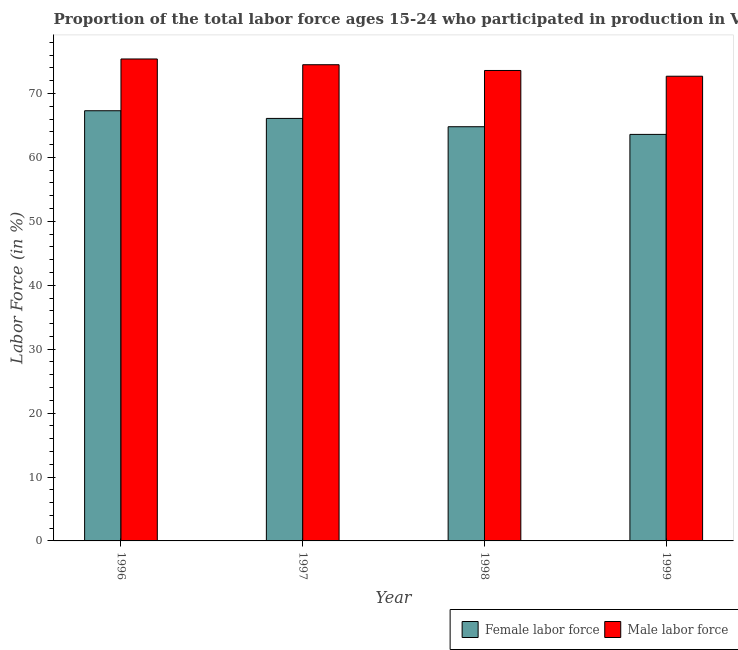How many bars are there on the 1st tick from the left?
Give a very brief answer. 2. How many bars are there on the 1st tick from the right?
Offer a terse response. 2. What is the percentage of male labour force in 1999?
Provide a succinct answer. 72.7. Across all years, what is the maximum percentage of female labor force?
Offer a very short reply. 67.3. Across all years, what is the minimum percentage of male labour force?
Ensure brevity in your answer.  72.7. In which year was the percentage of female labor force minimum?
Give a very brief answer. 1999. What is the total percentage of female labor force in the graph?
Provide a short and direct response. 261.8. What is the difference between the percentage of male labour force in 1997 and that in 1998?
Your answer should be compact. 0.9. What is the difference between the percentage of female labor force in 1997 and the percentage of male labour force in 1998?
Your answer should be very brief. 1.3. What is the average percentage of male labour force per year?
Provide a short and direct response. 74.05. What is the ratio of the percentage of female labor force in 1997 to that in 1999?
Provide a succinct answer. 1.04. Is the percentage of female labor force in 1996 less than that in 1997?
Offer a terse response. No. What is the difference between the highest and the second highest percentage of male labour force?
Ensure brevity in your answer.  0.9. What is the difference between the highest and the lowest percentage of male labour force?
Offer a very short reply. 2.7. Is the sum of the percentage of male labour force in 1996 and 1999 greater than the maximum percentage of female labor force across all years?
Keep it short and to the point. Yes. What does the 1st bar from the left in 1997 represents?
Your answer should be very brief. Female labor force. What does the 2nd bar from the right in 1996 represents?
Offer a terse response. Female labor force. Are the values on the major ticks of Y-axis written in scientific E-notation?
Your answer should be compact. No. Does the graph contain any zero values?
Your answer should be very brief. No. Does the graph contain grids?
Offer a terse response. No. What is the title of the graph?
Keep it short and to the point. Proportion of the total labor force ages 15-24 who participated in production in Vanuatu. What is the label or title of the X-axis?
Give a very brief answer. Year. What is the Labor Force (in %) of Female labor force in 1996?
Offer a very short reply. 67.3. What is the Labor Force (in %) in Male labor force in 1996?
Give a very brief answer. 75.4. What is the Labor Force (in %) in Female labor force in 1997?
Your response must be concise. 66.1. What is the Labor Force (in %) of Male labor force in 1997?
Provide a short and direct response. 74.5. What is the Labor Force (in %) in Female labor force in 1998?
Your answer should be very brief. 64.8. What is the Labor Force (in %) of Male labor force in 1998?
Keep it short and to the point. 73.6. What is the Labor Force (in %) in Female labor force in 1999?
Keep it short and to the point. 63.6. What is the Labor Force (in %) of Male labor force in 1999?
Your answer should be compact. 72.7. Across all years, what is the maximum Labor Force (in %) in Female labor force?
Offer a terse response. 67.3. Across all years, what is the maximum Labor Force (in %) of Male labor force?
Your response must be concise. 75.4. Across all years, what is the minimum Labor Force (in %) in Female labor force?
Give a very brief answer. 63.6. Across all years, what is the minimum Labor Force (in %) in Male labor force?
Make the answer very short. 72.7. What is the total Labor Force (in %) of Female labor force in the graph?
Keep it short and to the point. 261.8. What is the total Labor Force (in %) of Male labor force in the graph?
Give a very brief answer. 296.2. What is the difference between the Labor Force (in %) of Male labor force in 1996 and that in 1997?
Offer a terse response. 0.9. What is the difference between the Labor Force (in %) of Male labor force in 1996 and that in 1999?
Keep it short and to the point. 2.7. What is the difference between the Labor Force (in %) of Female labor force in 1997 and that in 1998?
Ensure brevity in your answer.  1.3. What is the difference between the Labor Force (in %) in Female labor force in 1997 and that in 1999?
Make the answer very short. 2.5. What is the difference between the Labor Force (in %) in Female labor force in 1998 and that in 1999?
Your answer should be compact. 1.2. What is the difference between the Labor Force (in %) in Female labor force in 1996 and the Labor Force (in %) in Male labor force in 1997?
Ensure brevity in your answer.  -7.2. What is the difference between the Labor Force (in %) of Female labor force in 1996 and the Labor Force (in %) of Male labor force in 1998?
Give a very brief answer. -6.3. What is the difference between the Labor Force (in %) in Female labor force in 1996 and the Labor Force (in %) in Male labor force in 1999?
Keep it short and to the point. -5.4. What is the difference between the Labor Force (in %) of Female labor force in 1997 and the Labor Force (in %) of Male labor force in 1998?
Your response must be concise. -7.5. What is the average Labor Force (in %) in Female labor force per year?
Keep it short and to the point. 65.45. What is the average Labor Force (in %) of Male labor force per year?
Make the answer very short. 74.05. In the year 1999, what is the difference between the Labor Force (in %) in Female labor force and Labor Force (in %) in Male labor force?
Offer a very short reply. -9.1. What is the ratio of the Labor Force (in %) in Female labor force in 1996 to that in 1997?
Give a very brief answer. 1.02. What is the ratio of the Labor Force (in %) in Male labor force in 1996 to that in 1997?
Your answer should be compact. 1.01. What is the ratio of the Labor Force (in %) in Female labor force in 1996 to that in 1998?
Your answer should be compact. 1.04. What is the ratio of the Labor Force (in %) of Male labor force in 1996 to that in 1998?
Keep it short and to the point. 1.02. What is the ratio of the Labor Force (in %) in Female labor force in 1996 to that in 1999?
Provide a succinct answer. 1.06. What is the ratio of the Labor Force (in %) in Male labor force in 1996 to that in 1999?
Offer a very short reply. 1.04. What is the ratio of the Labor Force (in %) of Female labor force in 1997 to that in 1998?
Provide a short and direct response. 1.02. What is the ratio of the Labor Force (in %) in Male labor force in 1997 to that in 1998?
Your answer should be compact. 1.01. What is the ratio of the Labor Force (in %) of Female labor force in 1997 to that in 1999?
Keep it short and to the point. 1.04. What is the ratio of the Labor Force (in %) of Male labor force in 1997 to that in 1999?
Your answer should be very brief. 1.02. What is the ratio of the Labor Force (in %) of Female labor force in 1998 to that in 1999?
Keep it short and to the point. 1.02. What is the ratio of the Labor Force (in %) of Male labor force in 1998 to that in 1999?
Provide a succinct answer. 1.01. What is the difference between the highest and the lowest Labor Force (in %) in Male labor force?
Your answer should be very brief. 2.7. 